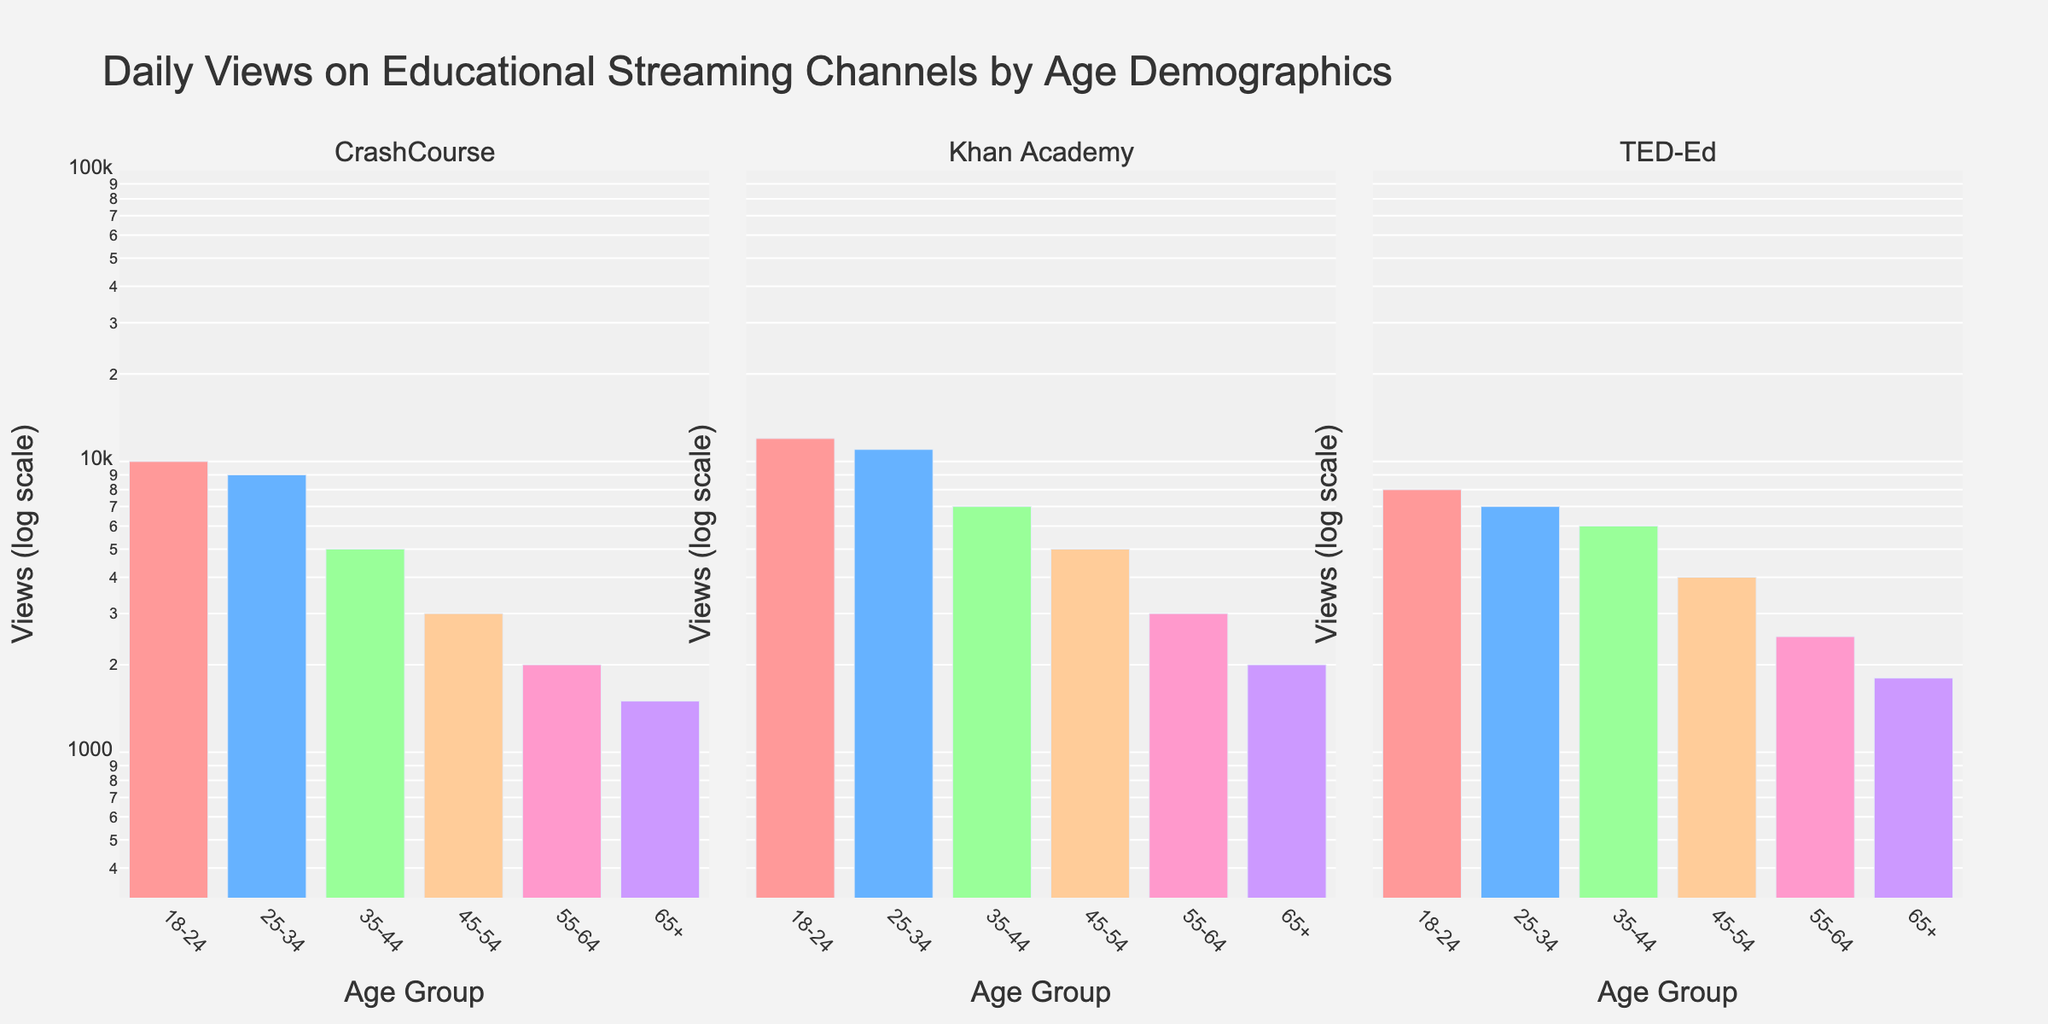How many age groups are shown in the figure? There are labels on the x-axis representing different age groups. Counting these labels gives the total number of age groups shown.
Answer: 6 Which channel has the highest views for the 18-24 age group? For the 18-24 age group, compare the heights of the bars in each subplot. The Khan Academy subplot has the highest bar for this group.
Answer: Khan Academy What is the general trend for views from younger to older age groups across all channels? Observing the heights of bars from left to right (younger to older age groups) in each subplot, we see a decreasing trend.
Answer: Decreasing Which channel shows the least difference in views between the 18-24 and 65+ age groups? By comparing the height difference of bars between 18-24 and 65+ age groups across the three subplots, TED-Ed shows the smallest difference.
Answer: TED-Ed What's the total number of views for the 25-34 age group across all three channels? Sum the heights of the bars for the 25-34 age group in all subplots: CrashCourse 9000 + Khan Academy 11000 + TED-Ed 7000.
Answer: 27000 For each age group, which channel observed the highest views? Look at each group and compare the bar heights within that group across the three subplots:
- 18-24: Khan Academy
- 25-34: Khan Academy
- 35-44: Khan Academy
- 45-54: Khan Academy
- 55-64: Khan Academy
- 65+: Khan Academy
Answer: Khan Academy for all What is the ratio of views for the 45-54 and 55-64 age groups for TED-Ed? Compare the heights of the bars for TED-Ed in the 45-54 and 55-64 age groups. Ratio = 4000 / 2500.
Answer: 1.6 Which age group shows the steepest decline in views from the previous age group for CrashCourse? Compare the relative drop in height of bars between consecutive age groups across the CrashCourse subplot. The biggest drop is from 45-54 to 55-64.
Answer: 45-54 to 55-64 At what age group does the Khan Academy channel start seeing less than 5000 views? In the Khan Academy subplot, observe at which age group the bar height drops below the 5000 view mark. This occurs at the 55-64 age group.
Answer: 55-64 What is the combined percentage of views for TED-Ed from the 18-24 and 65+ age groups out of the total views for TED-Ed? For TED-Ed, sum the views for 18-24 and 65+ groups, then divide by the total views for TED-Ed and multiply by 100:
- Views in 18-24 = 8000
- Views in 65+ = 1800
- Total TED-Ed views = 8000 + 7000 + 6000 + 4000 + 2500 + 1800 = 29300
- Combined percentage = (8000 + 1800) / 29300 * 100
Answer: ~33.45% 